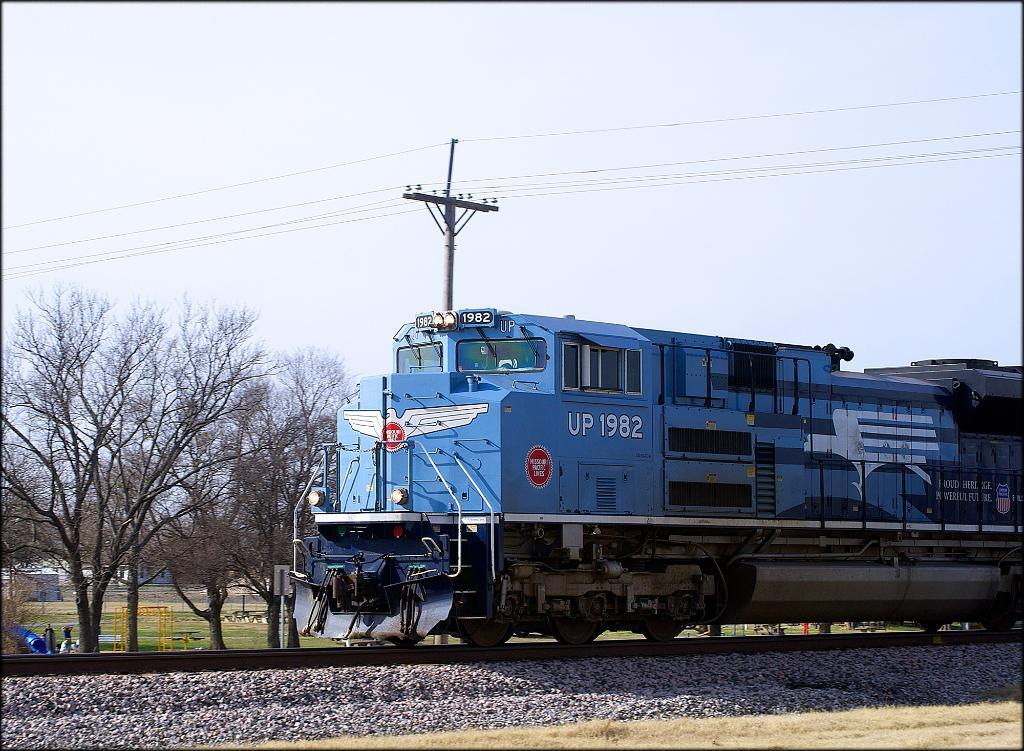<image>
Write a terse but informative summary of the picture. Blue train that has the plate UP1982 on the tracks. 